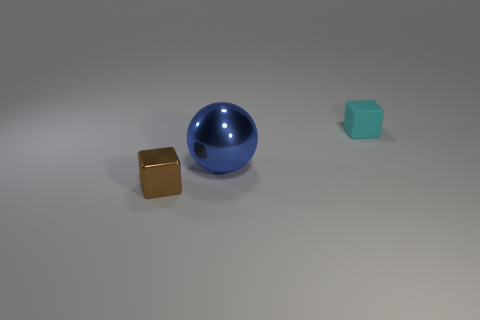Add 3 small brown shiny objects. How many objects exist? 6 Subtract all blocks. How many objects are left? 1 Add 1 small shiny objects. How many small shiny objects exist? 2 Subtract 0 purple cylinders. How many objects are left? 3 Subtract all blue spheres. Subtract all brown blocks. How many objects are left? 1 Add 1 rubber objects. How many rubber objects are left? 2 